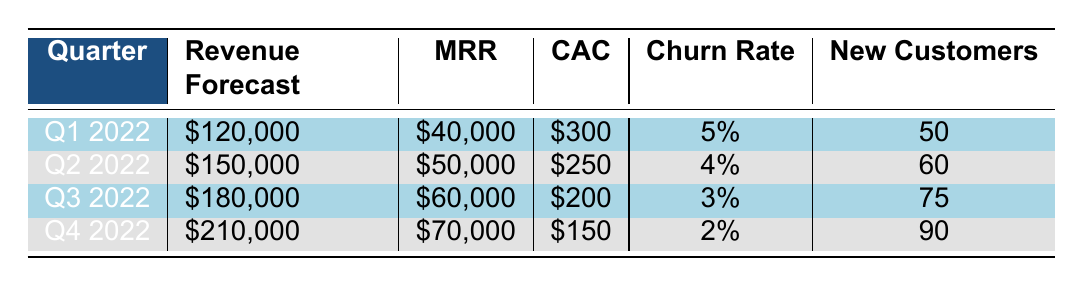What is the revenue forecast for Q3 2022? The revenue forecast for Q3 2022 is listed directly in the table under the respective quarter. In the row for Q3 2022, the revenue forecast is $180,000.
Answer: 180000 What is the churn rate for Q2 2022? The churn rate for Q2 2022 can be found by looking at the row for that quarter in the table. It is specified as 4%.
Answer: 4% How many new customers are expected in Q4 2022? The expected number of new customers for Q4 2022 is provided in the corresponding row. For Q4 2022, it states there will be 90 new customers.
Answer: 90 What is the difference in revenue forecast between Q1 2022 and Q4 2022? To find the difference in revenue forecasts, subtract the revenue forecast for Q1 2022 ($120,000) from that for Q4 2022 ($210,000). The calculation is $210,000 - $120,000 = $90,000.
Answer: 90000 Is the customer acquisition cost decreasing from Q1 to Q4 2022? By examining the customer acquisition cost (CAC) for each quarter in the table: Q1 is $300, Q2 is $250, Q3 is $200, and Q4 is $150. The CAC decreases consistently over these quarters, which confirms that it is indeed decreasing.
Answer: Yes What is the average monthly recurring revenue (MRR) forecast over the four quarters? To calculate the average MRR, first sum the MRRs for each quarter: $40,000 (Q1) + $50,000 (Q2) + $60,000 (Q3) + $70,000 (Q4) = $220,000. Since there are four quarters, divide the sum by 4, resulting in $220,000 / 4 = $55,000.
Answer: 55000 In which quarter is the churn rate the lowest? The churn rates listed are 5% for Q1, 4% for Q2, 3% for Q3, and 2% for Q4. The lowest churn rate is identified in the Q4 2022 row, where the churn rate is 2%.
Answer: Q4 2022 How much new revenue is anticipated from new customers in Q3 2022 if the average customer paying $800 monthly? The total new revenue from new customers can be calculated by multiplying the number of new customers (75) by the MRR per customer ($800). Thus, 75 customers x $800 = $60,000.
Answer: 60000 